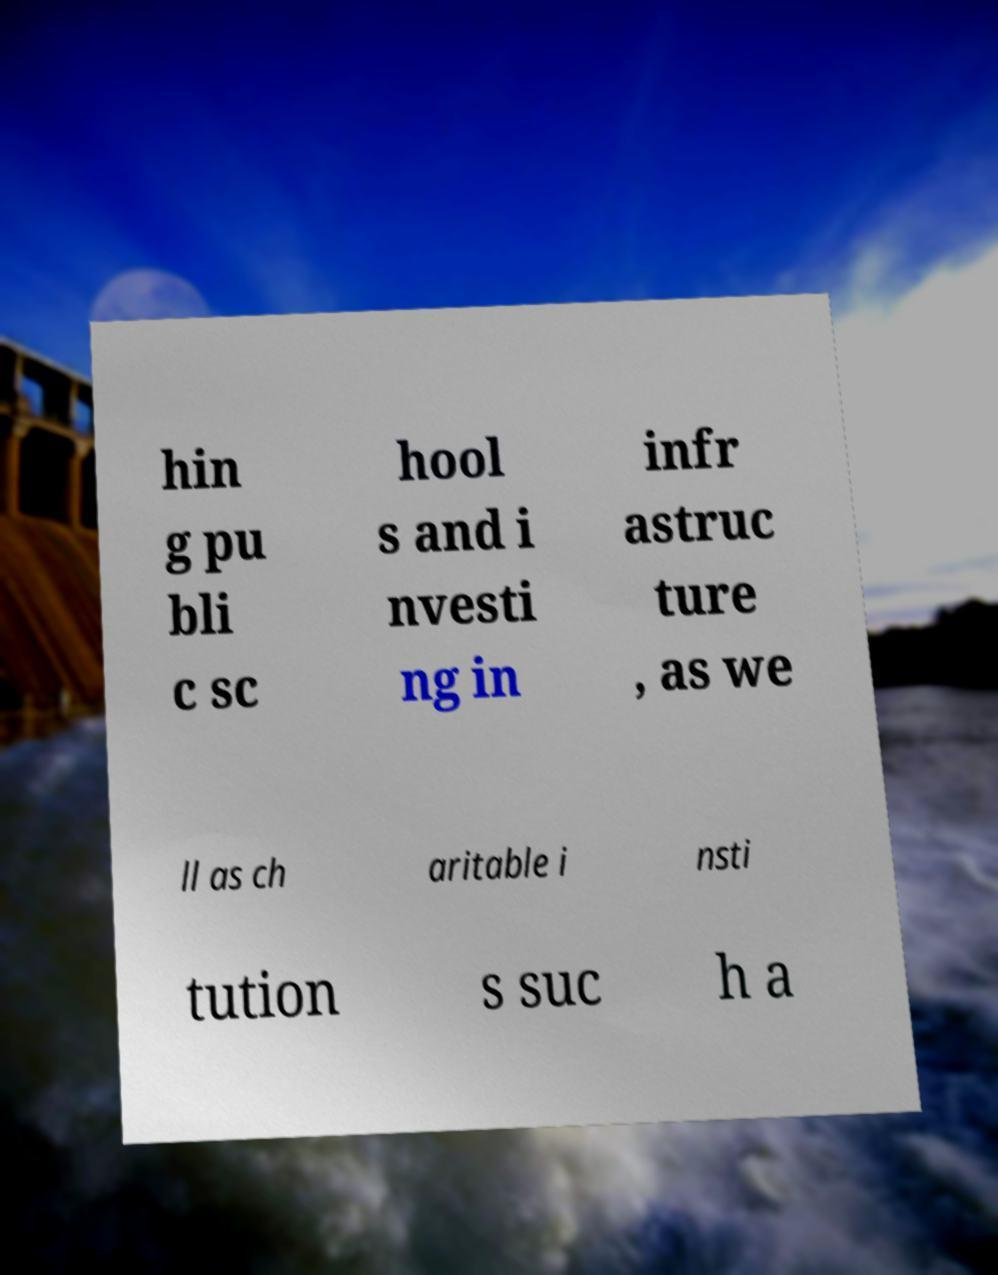Can you read and provide the text displayed in the image?This photo seems to have some interesting text. Can you extract and type it out for me? hin g pu bli c sc hool s and i nvesti ng in infr astruc ture , as we ll as ch aritable i nsti tution s suc h a 